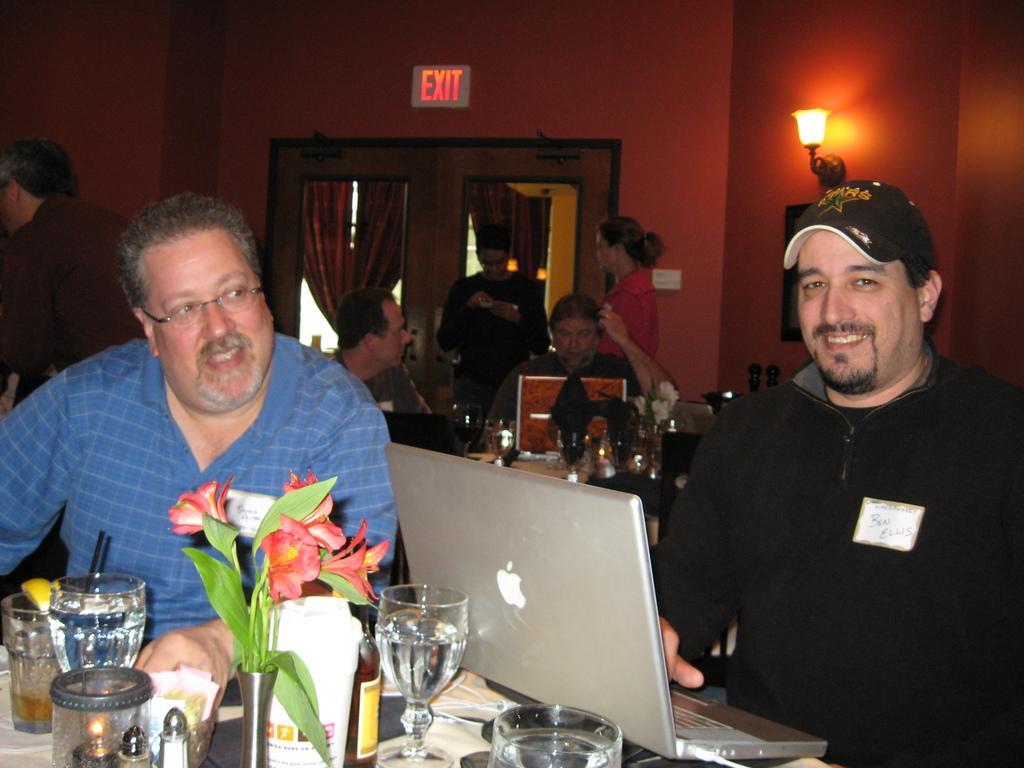Could you give a brief overview of what you see in this image? In this picture there is a man who is sitting near to the table. On the table I can see the laptop, water glasses, flowers, tissue paper, plant and other objects. On the right there is a man who is wearing cap and black dress. In the back there are two men who are sitting near to the table. On that table I can see the laptop, water glasses and other objects. In front of the door I can see two persons were standing. At the top there is a sign board. In the top right corner there is a light which is placed on the wall. On the left I can see two persons who are standing near to the wall. 